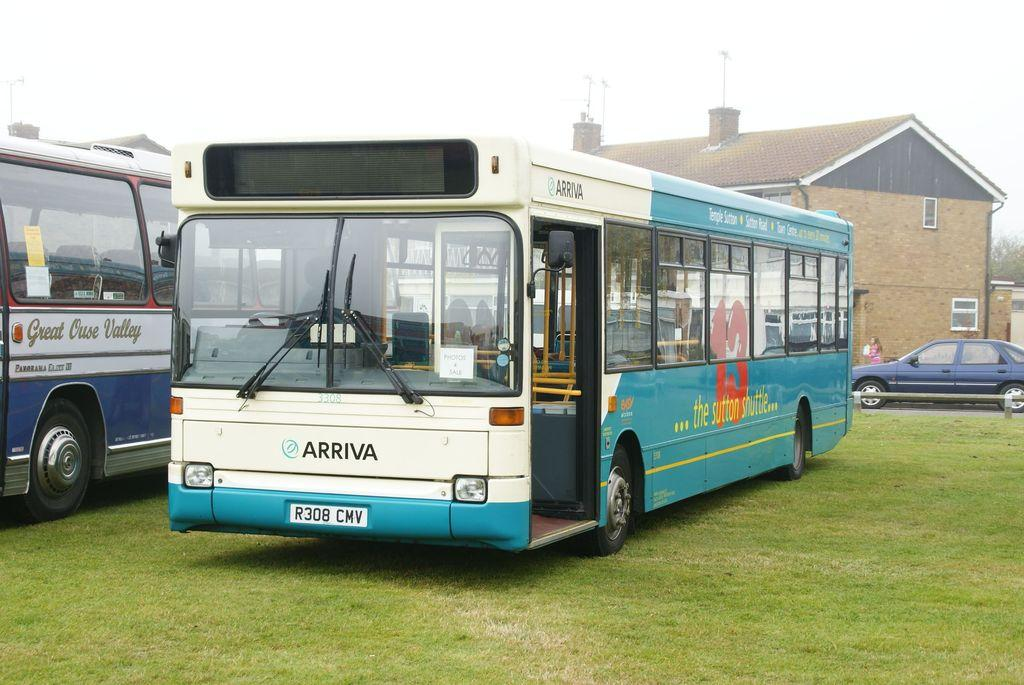What type of vehicles are on the grass in the image? There are buses on the grass in the image. What structures can be seen in the background of the image? There are houses in the background of the image. What else can be seen on the road in the background of the image? There are cars on the road in the background of the image. What is visible at the top of the image? The sky is visible at the top of the image. What color of paint is being used by the buses on the grass? There is no information about the color of paint being used by the buses in the image. What is the tendency of the need for transportation in the image? The image does not provide information about the need for transportation or any tendencies related to it. 